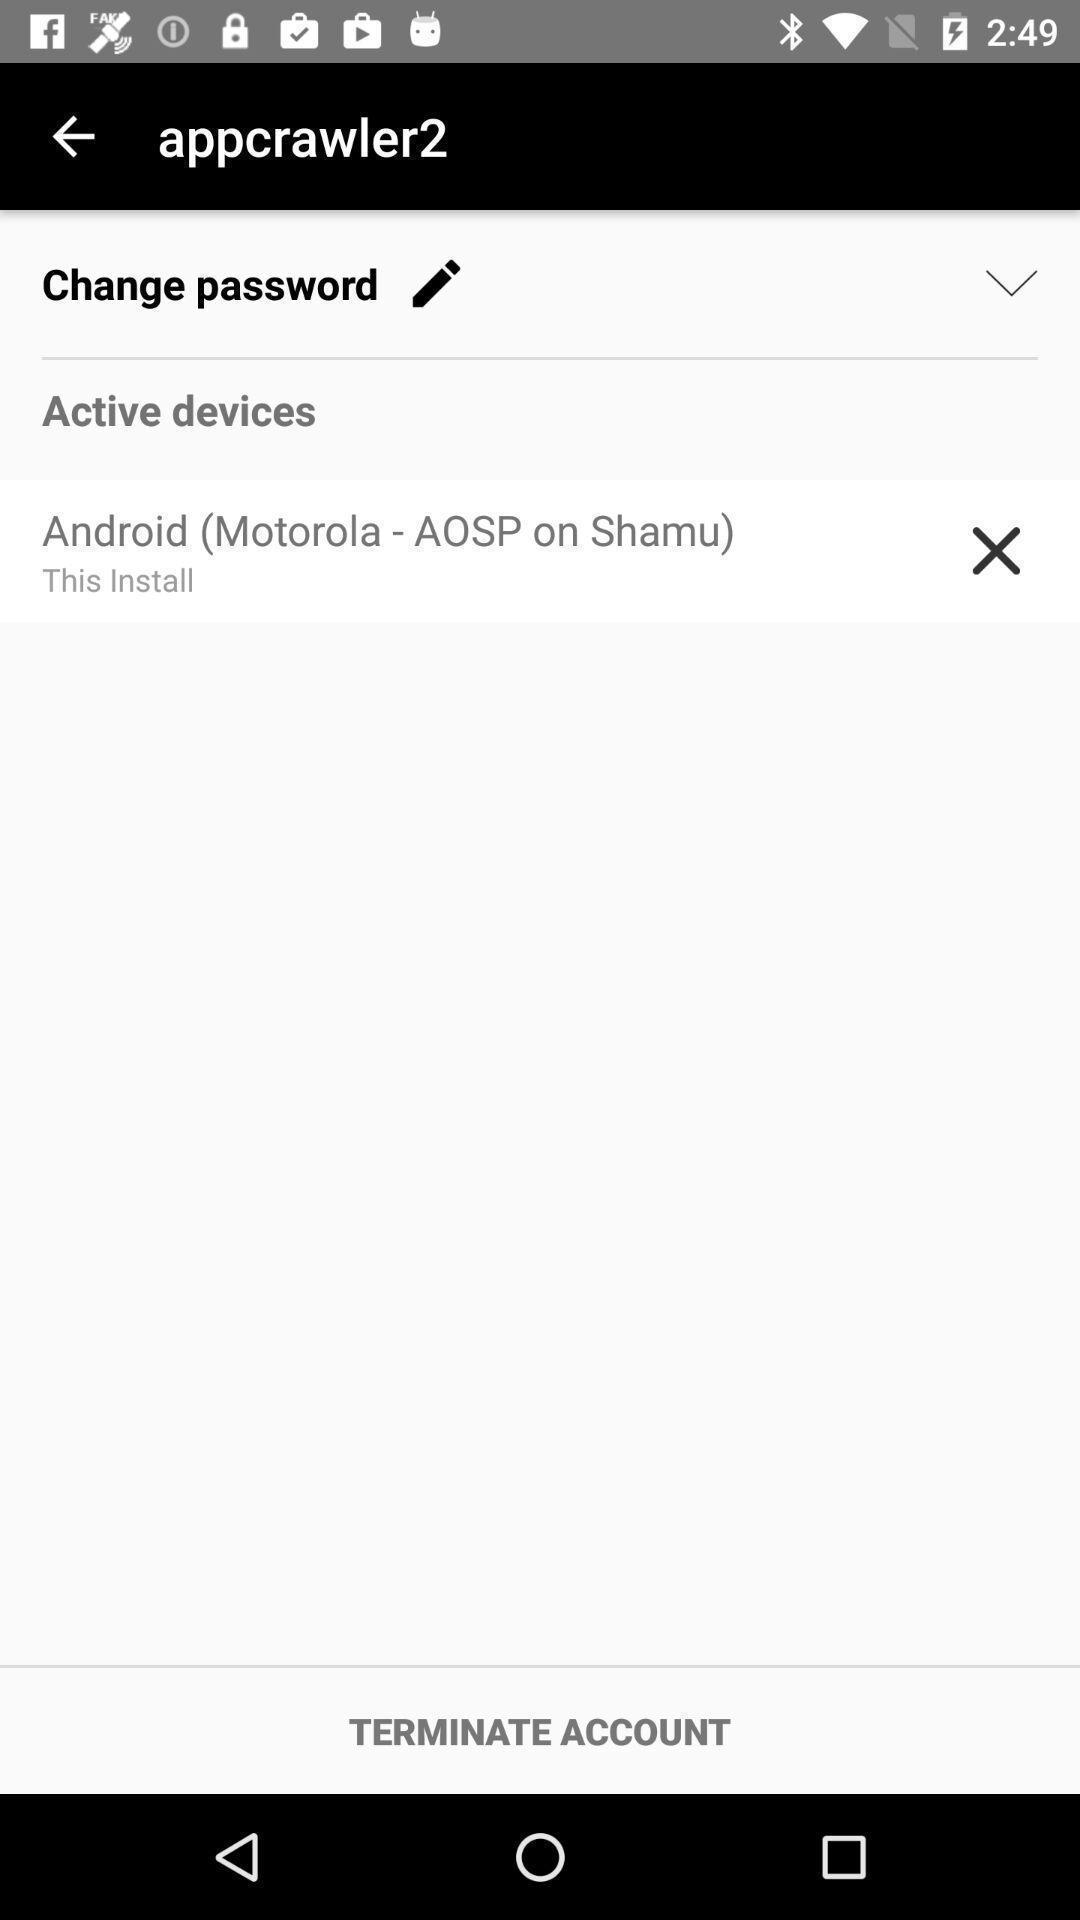Describe the content in this image. Terminate account page in a calling app. 